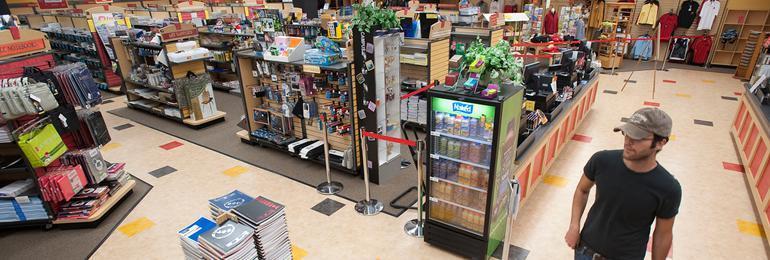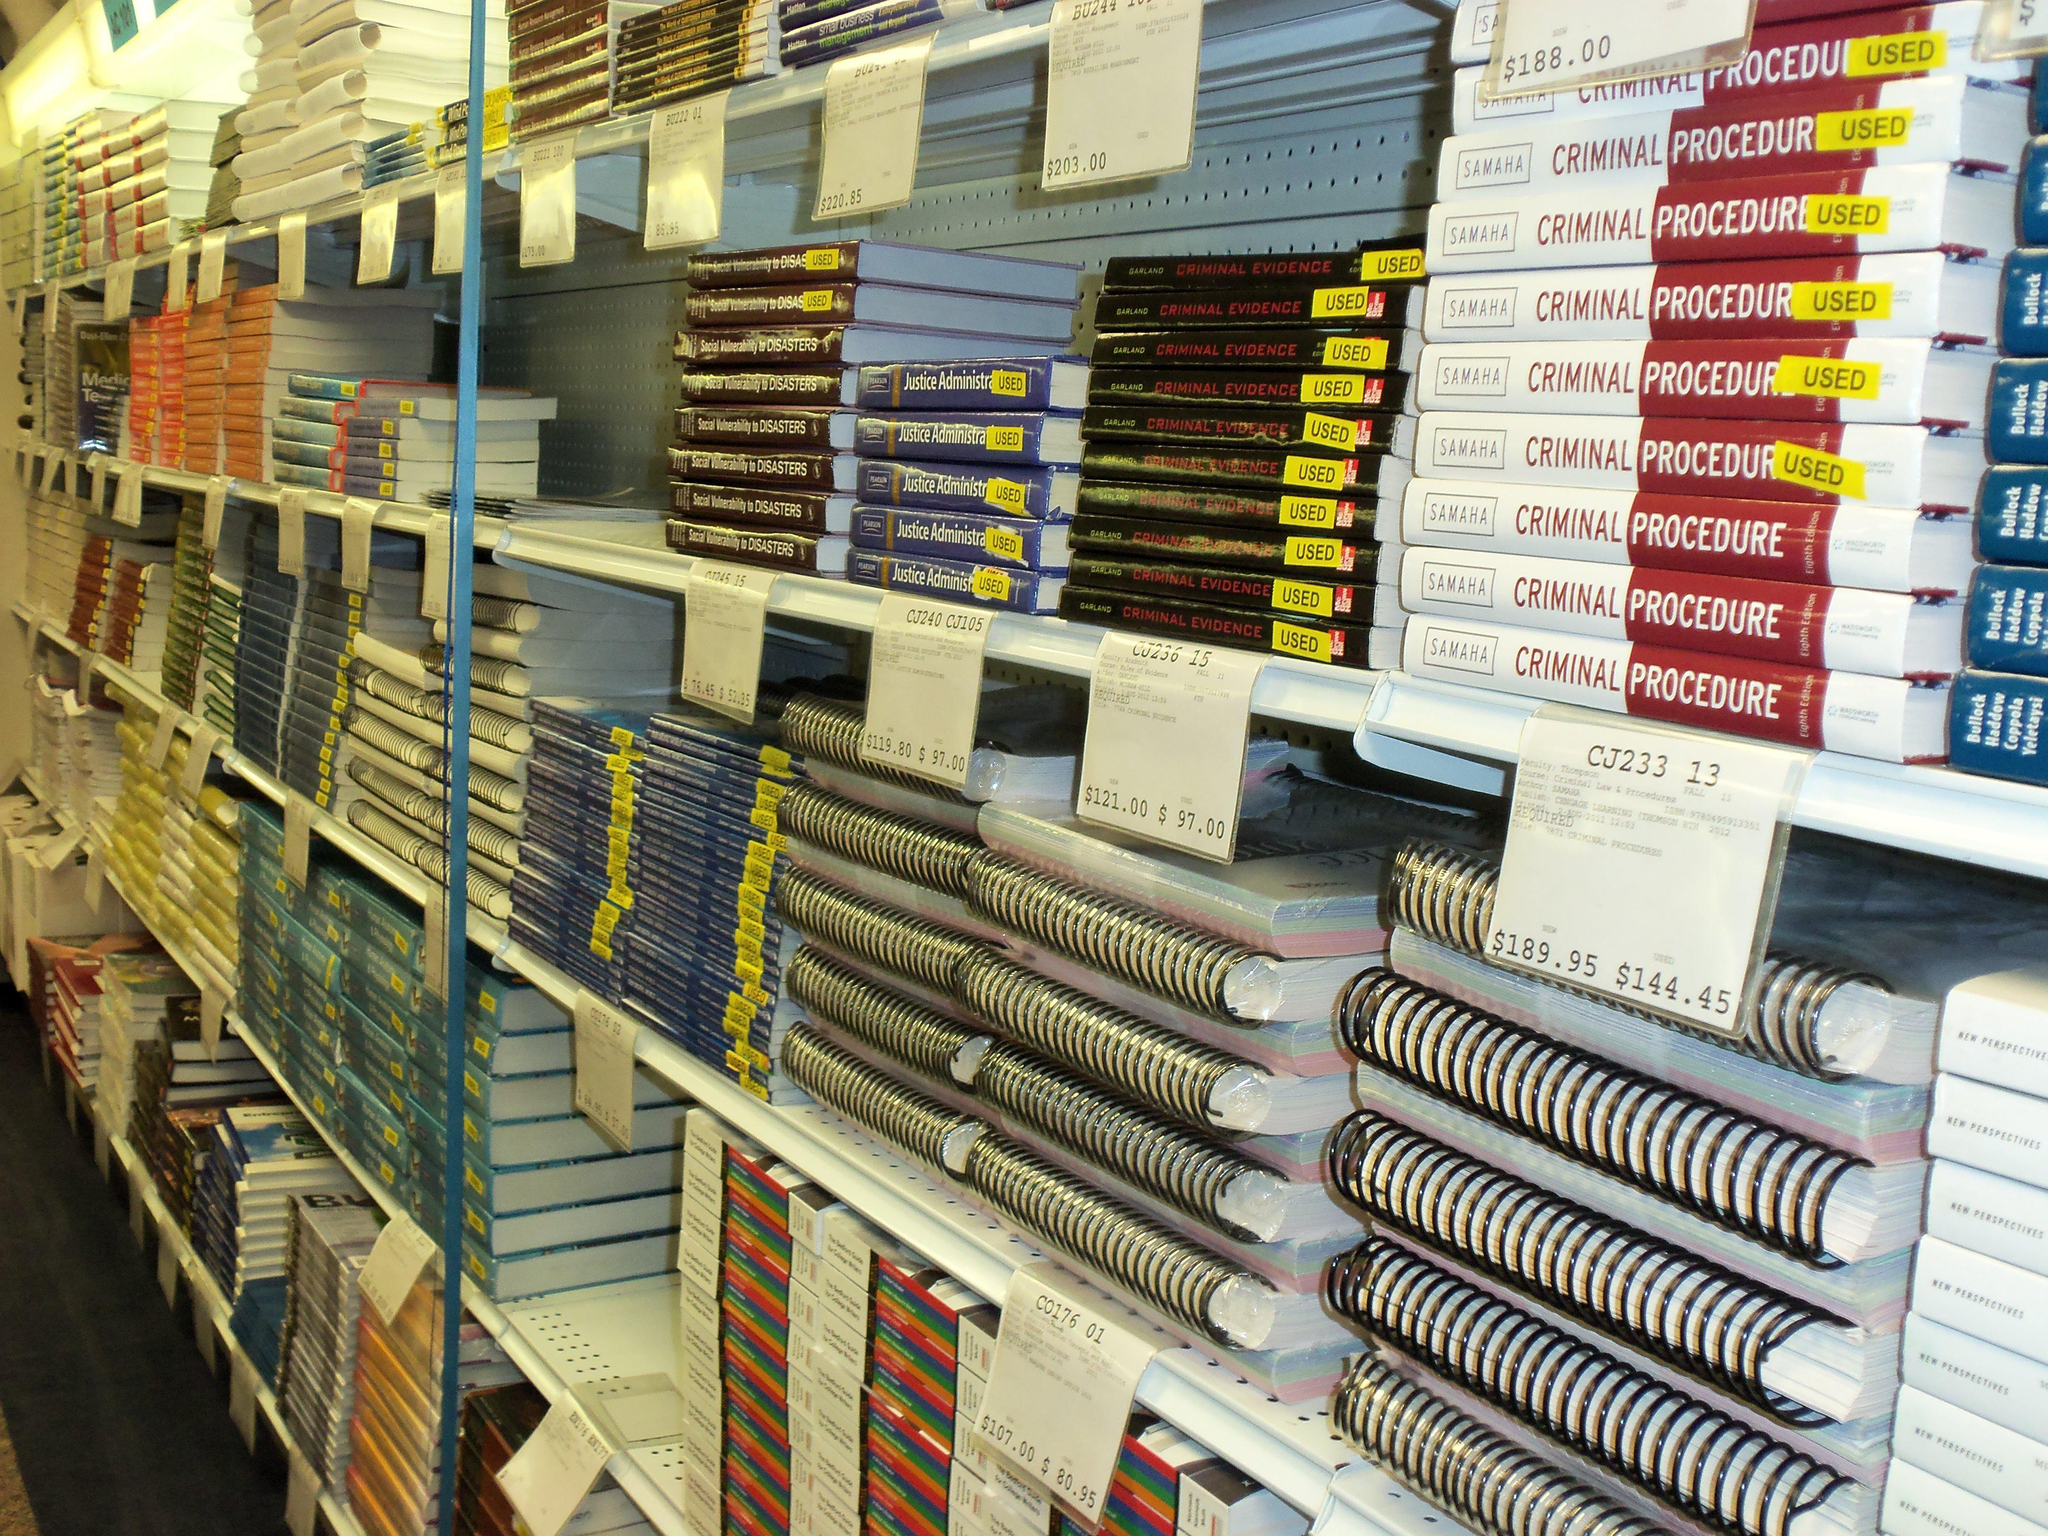The first image is the image on the left, the second image is the image on the right. For the images displayed, is the sentence "A woman in the image on the left has her hand on a rack." factually correct? Answer yes or no. No. The first image is the image on the left, the second image is the image on the right. For the images displayed, is the sentence "IN at least one image there is only a single woman with long hair browsing the store." factually correct? Answer yes or no. No. 